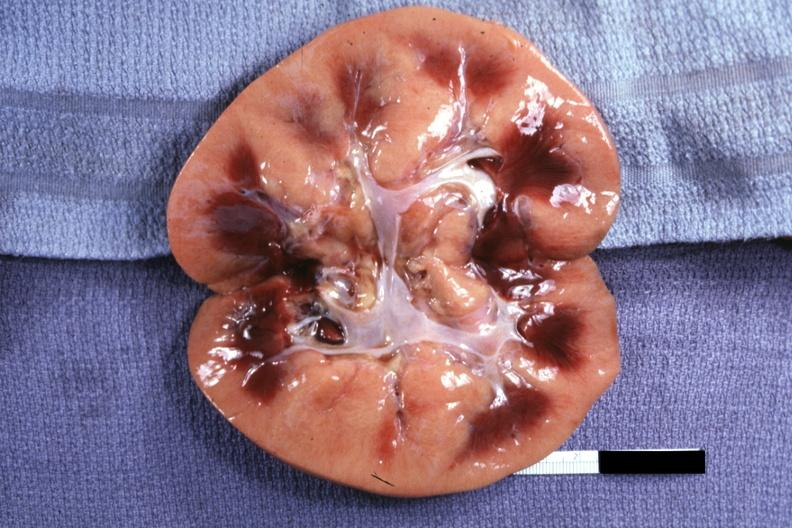does this myoma show obviously greatly swollen and pale kidney?
Answer the question using a single word or phrase. No 